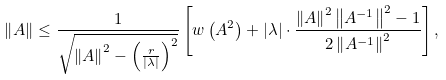<formula> <loc_0><loc_0><loc_500><loc_500>\left \| A \right \| \leq \frac { 1 } { \sqrt { \left \| A \right \| ^ { 2 } - \left ( \frac { r } { \left | \lambda \right | } \right ) ^ { 2 } } } \left [ w \left ( A ^ { 2 } \right ) + \left | \lambda \right | \cdot \frac { \left \| A \right \| ^ { 2 } \left \| A ^ { - 1 } \right \| ^ { 2 } - 1 } { 2 \left \| A ^ { - 1 } \right \| ^ { 2 } } \right ] ,</formula> 